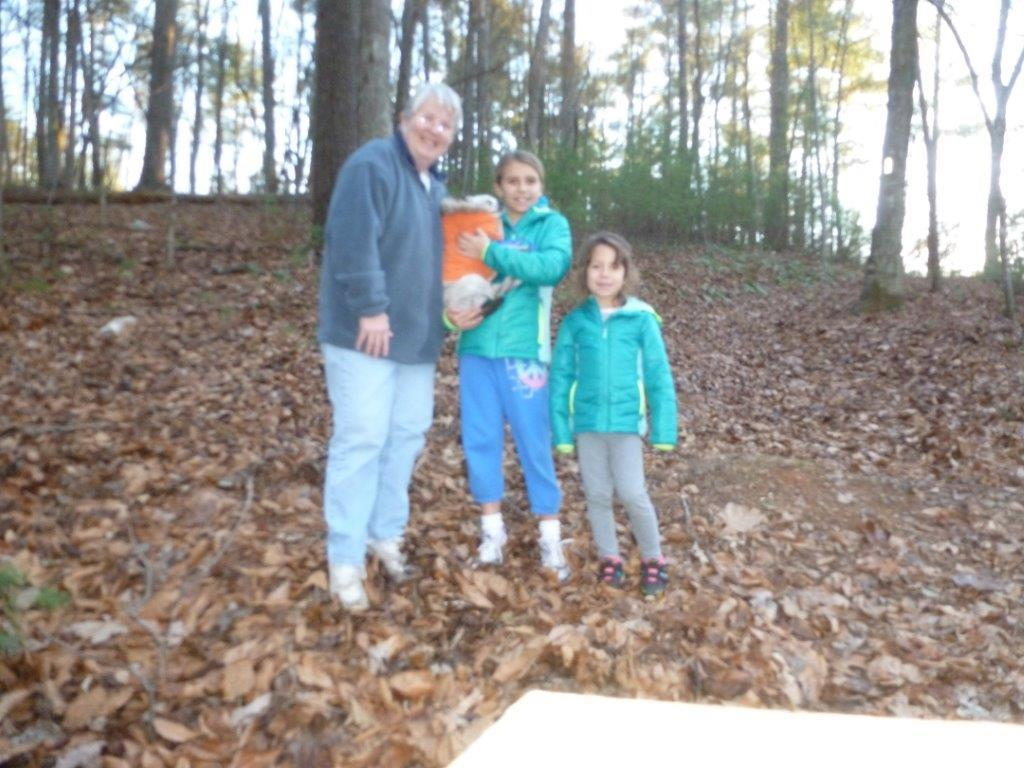How many people are in the image? There is one person and two children in the image. What are the people standing on? The people are standing on dry leaves. What can be seen in the background of the image? There are trees in the background of the image. What type of twig is being used as a pump in the image? There is no twig or pump present in the image. What kind of vessel is being carried by the person in the image? There is no vessel being carried by the person in the image. 